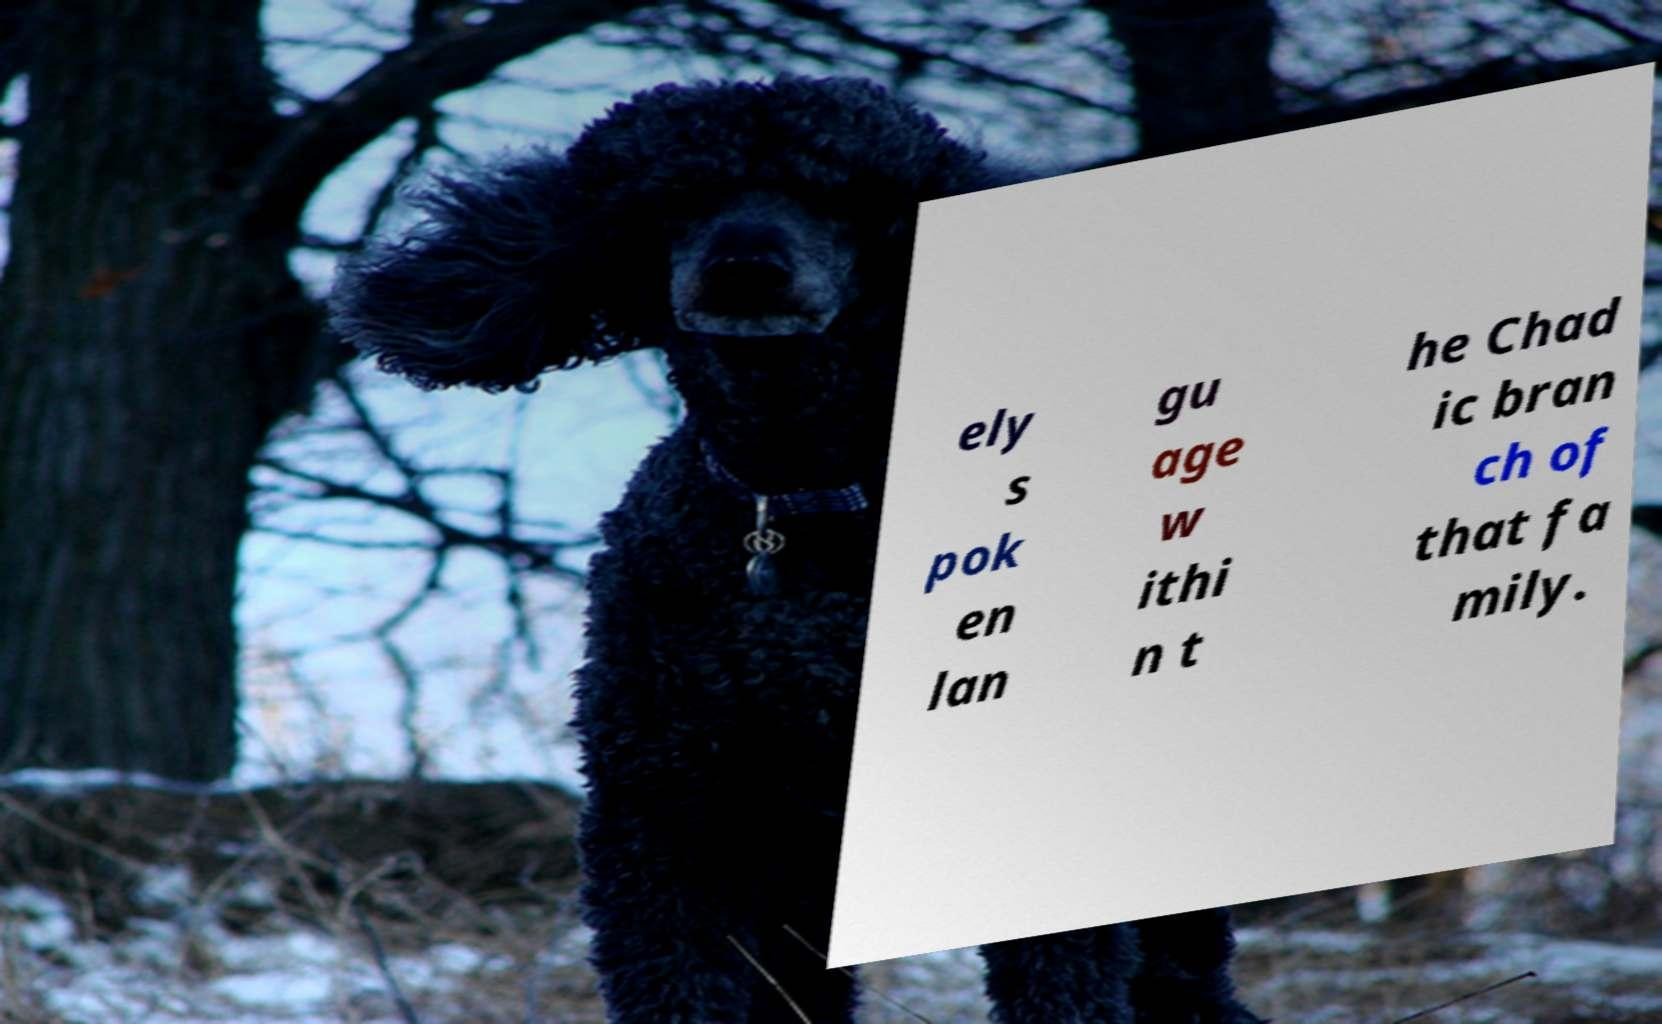Please identify and transcribe the text found in this image. ely s pok en lan gu age w ithi n t he Chad ic bran ch of that fa mily. 